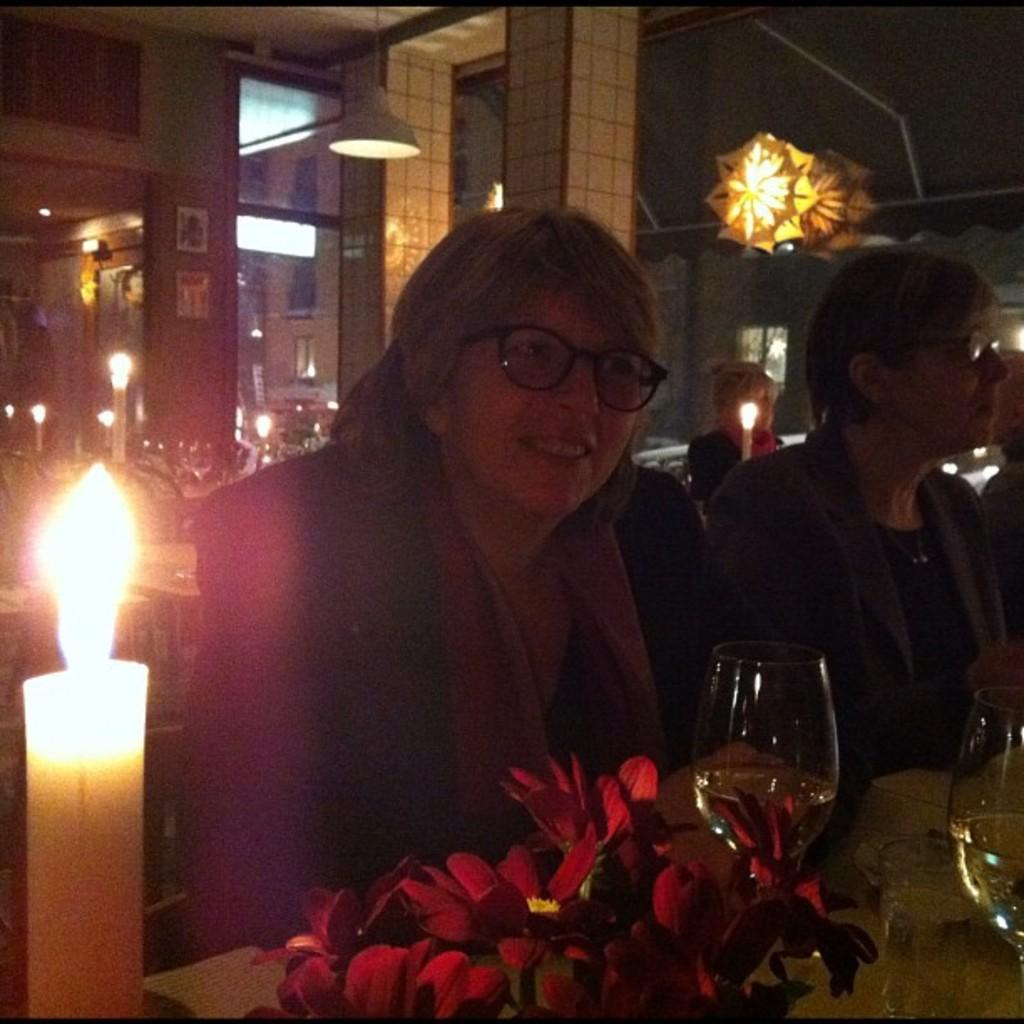What is the woman in the image doing? The woman is sitting in the image. What expression does the woman have? The woman is smiling. What can be seen on the left side of the image? There is a candle burning on the left side of the image. What can be seen on the right side of the image? There are wine glasses on the right side of the image. Where is the toy located in the image? There is no toy present in the image. What type of hook is used to hang the tent in the image? There is no tent present in the image. 